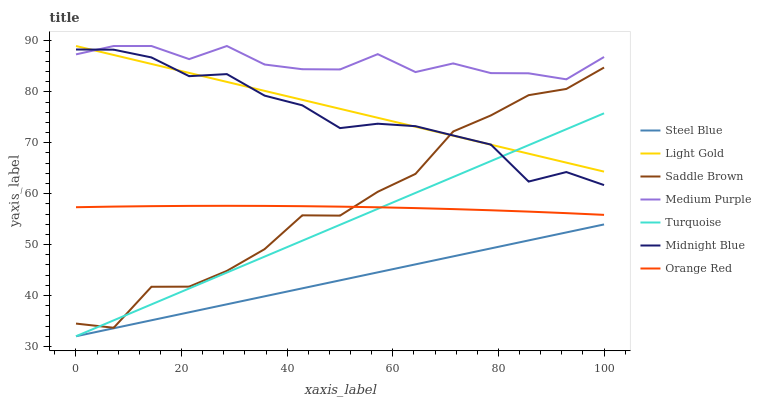Does Steel Blue have the minimum area under the curve?
Answer yes or no. Yes. Does Medium Purple have the maximum area under the curve?
Answer yes or no. Yes. Does Midnight Blue have the minimum area under the curve?
Answer yes or no. No. Does Midnight Blue have the maximum area under the curve?
Answer yes or no. No. Is Steel Blue the smoothest?
Answer yes or no. Yes. Is Saddle Brown the roughest?
Answer yes or no. Yes. Is Midnight Blue the smoothest?
Answer yes or no. No. Is Midnight Blue the roughest?
Answer yes or no. No. Does Turquoise have the lowest value?
Answer yes or no. Yes. Does Midnight Blue have the lowest value?
Answer yes or no. No. Does Light Gold have the highest value?
Answer yes or no. Yes. Does Midnight Blue have the highest value?
Answer yes or no. No. Is Steel Blue less than Saddle Brown?
Answer yes or no. Yes. Is Medium Purple greater than Turquoise?
Answer yes or no. Yes. Does Turquoise intersect Midnight Blue?
Answer yes or no. Yes. Is Turquoise less than Midnight Blue?
Answer yes or no. No. Is Turquoise greater than Midnight Blue?
Answer yes or no. No. Does Steel Blue intersect Saddle Brown?
Answer yes or no. No. 